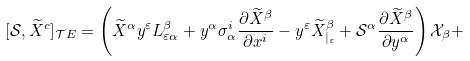Convert formula to latex. <formula><loc_0><loc_0><loc_500><loc_500>[ \mathcal { S } , \widetilde { X } ^ { c } ] _ { \mathcal { T } E } = \left ( \widetilde { X } ^ { \alpha } y ^ { \varepsilon } L _ { \varepsilon \alpha } ^ { \beta } + y ^ { \alpha } \sigma _ { \alpha } ^ { i } \frac { \partial \widetilde { X } ^ { \beta } } { \partial x ^ { i } } - y ^ { \varepsilon } \widetilde { X } _ { | _ { \varepsilon } } ^ { \beta } + \mathcal { S } ^ { \alpha } \frac { \partial \widetilde { X } ^ { \beta } } { \partial y ^ { \alpha } } \right ) \mathcal { X } _ { \beta } +</formula> 